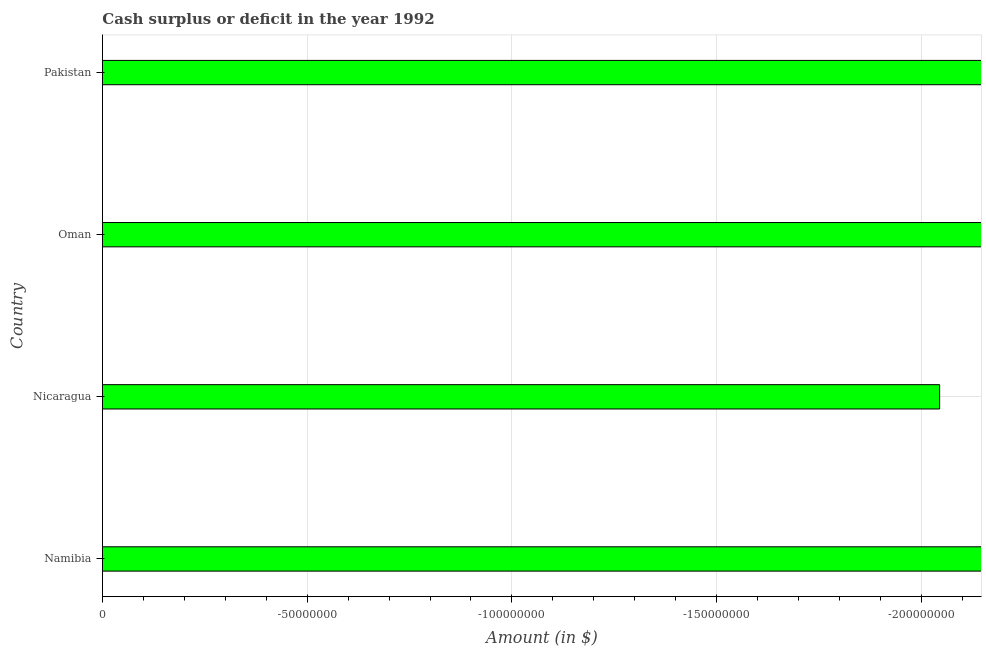Does the graph contain grids?
Ensure brevity in your answer.  Yes. What is the title of the graph?
Provide a succinct answer. Cash surplus or deficit in the year 1992. What is the label or title of the X-axis?
Make the answer very short. Amount (in $). What is the cash surplus or deficit in Pakistan?
Your answer should be very brief. 0. What is the sum of the cash surplus or deficit?
Give a very brief answer. 0. What is the average cash surplus or deficit per country?
Your answer should be very brief. 0. Are all the bars in the graph horizontal?
Offer a terse response. Yes. Are the values on the major ticks of X-axis written in scientific E-notation?
Give a very brief answer. No. What is the Amount (in $) in Namibia?
Provide a succinct answer. 0. What is the Amount (in $) in Nicaragua?
Your answer should be compact. 0. What is the Amount (in $) in Oman?
Your answer should be compact. 0. 